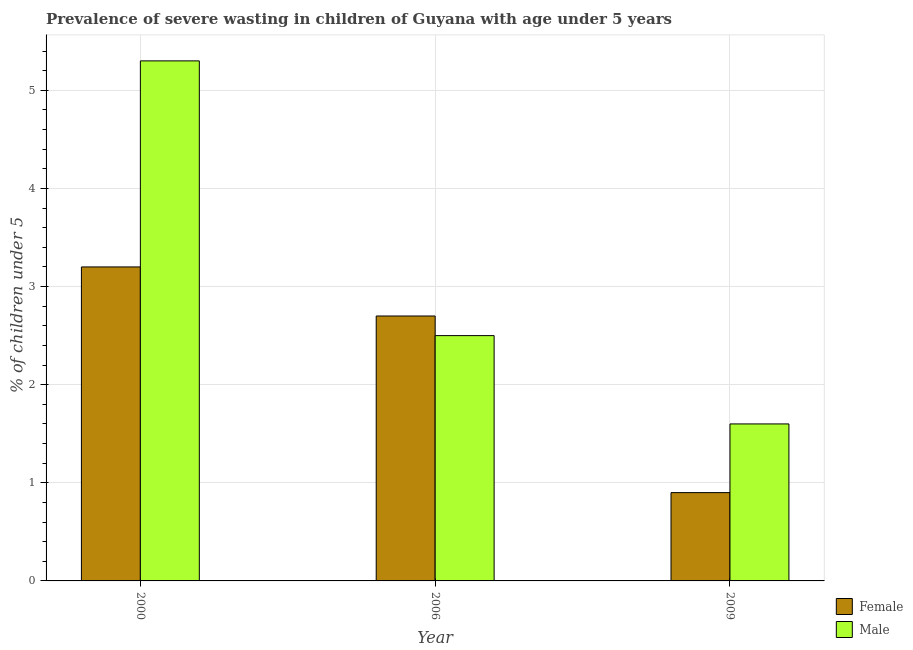How many different coloured bars are there?
Offer a terse response. 2. Are the number of bars on each tick of the X-axis equal?
Give a very brief answer. Yes. How many bars are there on the 3rd tick from the right?
Provide a short and direct response. 2. What is the label of the 1st group of bars from the left?
Offer a very short reply. 2000. In how many cases, is the number of bars for a given year not equal to the number of legend labels?
Offer a terse response. 0. What is the percentage of undernourished female children in 2000?
Your answer should be very brief. 3.2. Across all years, what is the maximum percentage of undernourished male children?
Your answer should be very brief. 5.3. Across all years, what is the minimum percentage of undernourished male children?
Give a very brief answer. 1.6. In which year was the percentage of undernourished female children minimum?
Your answer should be compact. 2009. What is the total percentage of undernourished male children in the graph?
Keep it short and to the point. 9.4. What is the difference between the percentage of undernourished female children in 2000 and that in 2009?
Keep it short and to the point. 2.3. What is the difference between the percentage of undernourished female children in 2009 and the percentage of undernourished male children in 2000?
Your answer should be compact. -2.3. What is the average percentage of undernourished male children per year?
Keep it short and to the point. 3.13. In the year 2006, what is the difference between the percentage of undernourished male children and percentage of undernourished female children?
Provide a succinct answer. 0. What is the ratio of the percentage of undernourished female children in 2006 to that in 2009?
Provide a succinct answer. 3. Is the difference between the percentage of undernourished female children in 2000 and 2009 greater than the difference between the percentage of undernourished male children in 2000 and 2009?
Offer a very short reply. No. What is the difference between the highest and the second highest percentage of undernourished male children?
Your response must be concise. 2.8. What is the difference between the highest and the lowest percentage of undernourished male children?
Ensure brevity in your answer.  3.7. Is the sum of the percentage of undernourished female children in 2000 and 2009 greater than the maximum percentage of undernourished male children across all years?
Keep it short and to the point. Yes. Are all the bars in the graph horizontal?
Ensure brevity in your answer.  No. How many years are there in the graph?
Offer a very short reply. 3. What is the difference between two consecutive major ticks on the Y-axis?
Offer a terse response. 1. Are the values on the major ticks of Y-axis written in scientific E-notation?
Your response must be concise. No. Does the graph contain any zero values?
Make the answer very short. No. What is the title of the graph?
Provide a succinct answer. Prevalence of severe wasting in children of Guyana with age under 5 years. What is the label or title of the Y-axis?
Keep it short and to the point.  % of children under 5. What is the  % of children under 5 in Female in 2000?
Keep it short and to the point. 3.2. What is the  % of children under 5 in Male in 2000?
Offer a very short reply. 5.3. What is the  % of children under 5 in Female in 2006?
Your response must be concise. 2.7. What is the  % of children under 5 in Female in 2009?
Offer a very short reply. 0.9. What is the  % of children under 5 of Male in 2009?
Keep it short and to the point. 1.6. Across all years, what is the maximum  % of children under 5 in Female?
Make the answer very short. 3.2. Across all years, what is the maximum  % of children under 5 of Male?
Provide a succinct answer. 5.3. Across all years, what is the minimum  % of children under 5 of Female?
Your answer should be compact. 0.9. Across all years, what is the minimum  % of children under 5 of Male?
Ensure brevity in your answer.  1.6. What is the total  % of children under 5 in Male in the graph?
Offer a very short reply. 9.4. What is the difference between the  % of children under 5 in Male in 2000 and that in 2006?
Provide a short and direct response. 2.8. What is the difference between the  % of children under 5 in Male in 2000 and that in 2009?
Your answer should be compact. 3.7. What is the difference between the  % of children under 5 in Female in 2006 and that in 2009?
Ensure brevity in your answer.  1.8. What is the difference between the  % of children under 5 in Female in 2006 and the  % of children under 5 in Male in 2009?
Give a very brief answer. 1.1. What is the average  % of children under 5 of Female per year?
Your answer should be compact. 2.27. What is the average  % of children under 5 of Male per year?
Offer a very short reply. 3.13. In the year 2000, what is the difference between the  % of children under 5 in Female and  % of children under 5 in Male?
Provide a succinct answer. -2.1. In the year 2006, what is the difference between the  % of children under 5 in Female and  % of children under 5 in Male?
Give a very brief answer. 0.2. In the year 2009, what is the difference between the  % of children under 5 of Female and  % of children under 5 of Male?
Your answer should be very brief. -0.7. What is the ratio of the  % of children under 5 in Female in 2000 to that in 2006?
Provide a short and direct response. 1.19. What is the ratio of the  % of children under 5 in Male in 2000 to that in 2006?
Offer a very short reply. 2.12. What is the ratio of the  % of children under 5 of Female in 2000 to that in 2009?
Your answer should be very brief. 3.56. What is the ratio of the  % of children under 5 of Male in 2000 to that in 2009?
Offer a very short reply. 3.31. What is the ratio of the  % of children under 5 of Male in 2006 to that in 2009?
Your answer should be compact. 1.56. What is the difference between the highest and the lowest  % of children under 5 in Female?
Ensure brevity in your answer.  2.3. What is the difference between the highest and the lowest  % of children under 5 in Male?
Provide a succinct answer. 3.7. 